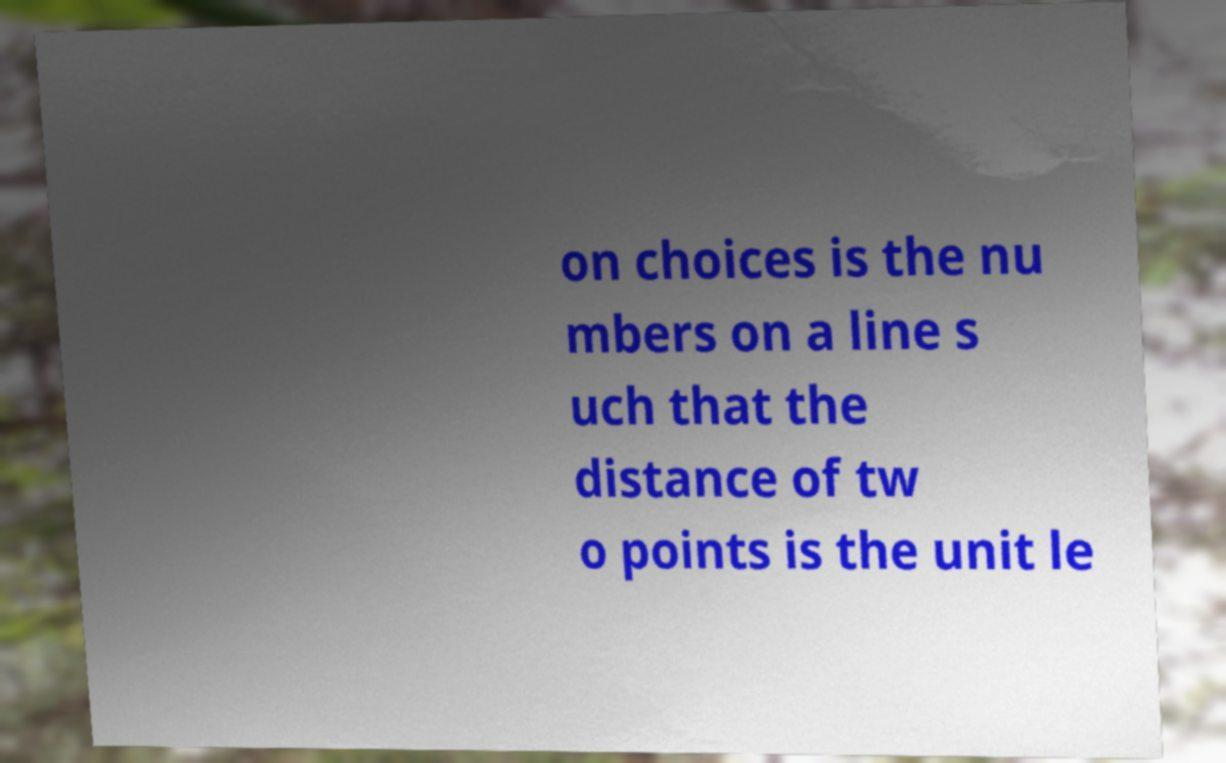For documentation purposes, I need the text within this image transcribed. Could you provide that? on choices is the nu mbers on a line s uch that the distance of tw o points is the unit le 